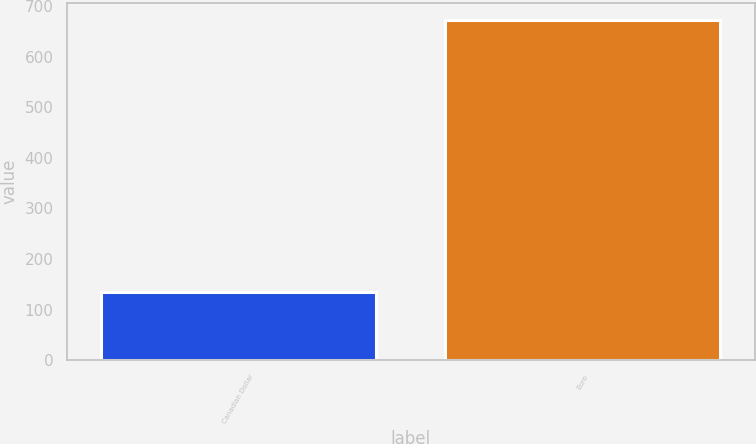Convert chart. <chart><loc_0><loc_0><loc_500><loc_500><bar_chart><fcel>Canadian Dollar<fcel>Euro<nl><fcel>135<fcel>673<nl></chart> 